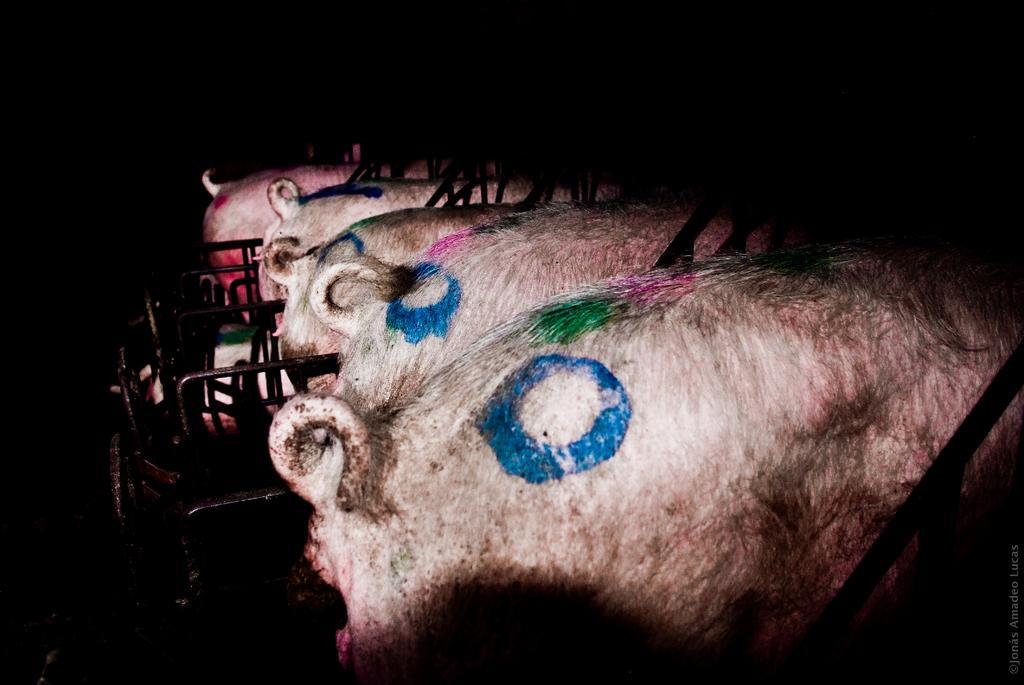Please provide a concise description of this image. In the picture we can see backside part of four pigs and on the top of the pigs we can see blue, green and pink colors and in the background we can see dark. 